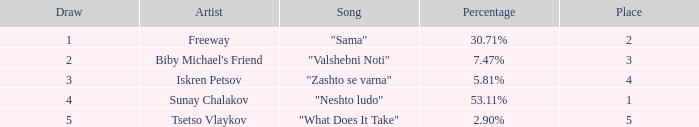I'm looking to parse the entire table for insights. Could you assist me with that? {'header': ['Draw', 'Artist', 'Song', 'Percentage', 'Place'], 'rows': [['1', 'Freeway', '"Sama"', '30.71%', '2'], ['2', "Biby Michael's Friend", '"Valshebni Noti"', '7.47%', '3'], ['3', 'Iskren Petsov', '"Zashto se varna"', '5.81%', '4'], ['4', 'Sunay Chalakov', '"Neshto ludo"', '53.11%', '1'], ['5', 'Tsetso Vlaykov', '"What Does It Take"', '2.90%', '5']]} 71%? 1.0. 